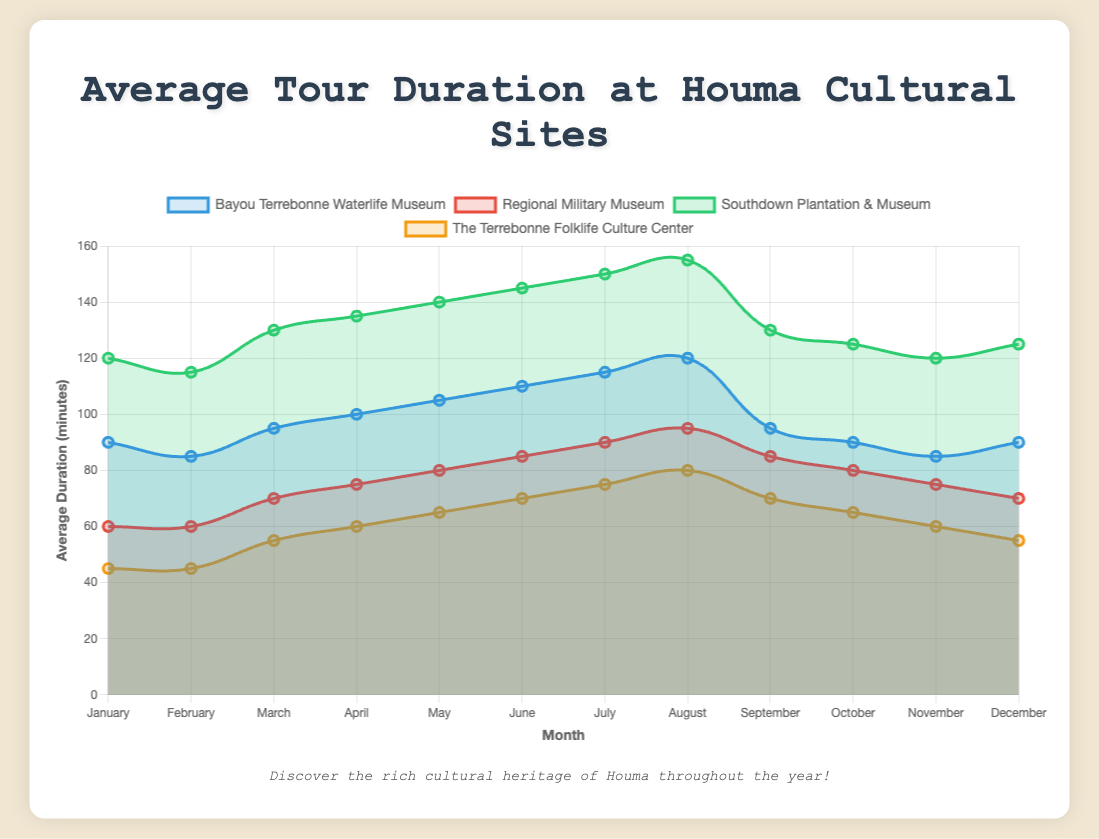How does the average tour duration at the Bayou Terrebonne Waterlife Museum in December compare to that in January? Look at the plot lines for 'Bayou Terrebonne Waterlife Museum' for December and January (both are at 90 minutes) and compare their heights directly.
Answer: The average durations are equal in December and January Which cultural site has the highest average tour duration in August? Examine the peak points of the plot lines in August for each site. 'Southdown Plantation & Museum' reaches the highest point at 155 minutes.
Answer: Southdown Plantation & Museum What is the difference in average tour duration between the longest and shortest visits in March? Identify the highest point ('Southdown Plantation & Museum' at 130 minutes) and the lowest point ('The Terrebonne Folklife Culture Center' at 55 minutes) in March, then calculate the difference.
Answer: 75 minutes Which site shows the most stable (least variation) average tour duration throughout the year? Observe the plot lines and identify the one with the flattest curve. The 'Regional Military Museum' has minimal fluctuation around 60 to 95 minutes.
Answer: Regional Military Museum What's the average duration of tours at the Southdown Plantation & Museum in the first quarter of the year? Sum the monthly values for January, February, and March (120 + 115 + 130 = 365) and divide by 3 months.
Answer: 121.67 minutes How does the average tour duration for the Regional Military Museum in July compare to that in June? Compare the data points for 'Regional Military Museum' for June (85 minutes) and July (90 minutes) by their heights.
Answer: The duration in July is 5 minutes longer than in June Which site has the highest increase in average tour duration from January to July? Calculate the difference in January and July for each site: 'Bayou Terrebonne Waterlife Museum' (25 minutes), 'Regional Military Museum' (30 minutes), 'Southdown Plantation & Museum' (30 minutes), and 'The Terrebonne Folklife Culture Center' (30 minutes).
Answer: The difference is the same (30 minutes) for multiple sites Is there any month where the average visit durations for all the sites tend to be close to each other? Identify months where the plot lines for all sites converge. The lines are closest in December with modest variations between 55 and 125 minutes.
Answer: December What can be said about the average duration of visits to The Terrebonne Folklife Culture Center across the year? Study the monthly data points for 'The Terrebonne Folklife Culture Center'; durations increase steadily to a peak in August (80 minutes) and decrease towards the end of the year.
Answer: It peaks in August and is otherwise relatively stable 